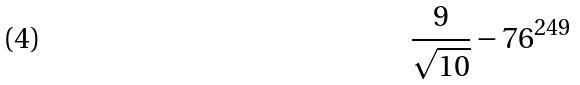Convert formula to latex. <formula><loc_0><loc_0><loc_500><loc_500>\frac { 9 } { \sqrt { 1 0 } } - 7 6 ^ { 2 4 9 }</formula> 